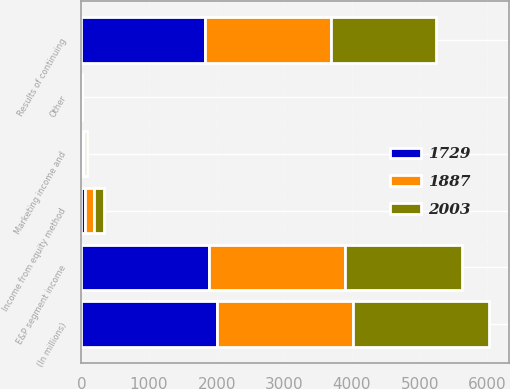Convert chart. <chart><loc_0><loc_0><loc_500><loc_500><stacked_bar_chart><ecel><fcel>(In millions)<fcel>Results of continuing<fcel>Marketing income and<fcel>Income from equity method<fcel>Other<fcel>E&P segment income<nl><fcel>2003<fcel>2007<fcel>1545<fcel>36<fcel>154<fcel>6<fcel>1729<nl><fcel>1887<fcel>2006<fcel>1858<fcel>40<fcel>135<fcel>1<fcel>2003<nl><fcel>1729<fcel>2005<fcel>1835<fcel>4<fcel>52<fcel>4<fcel>1887<nl></chart> 